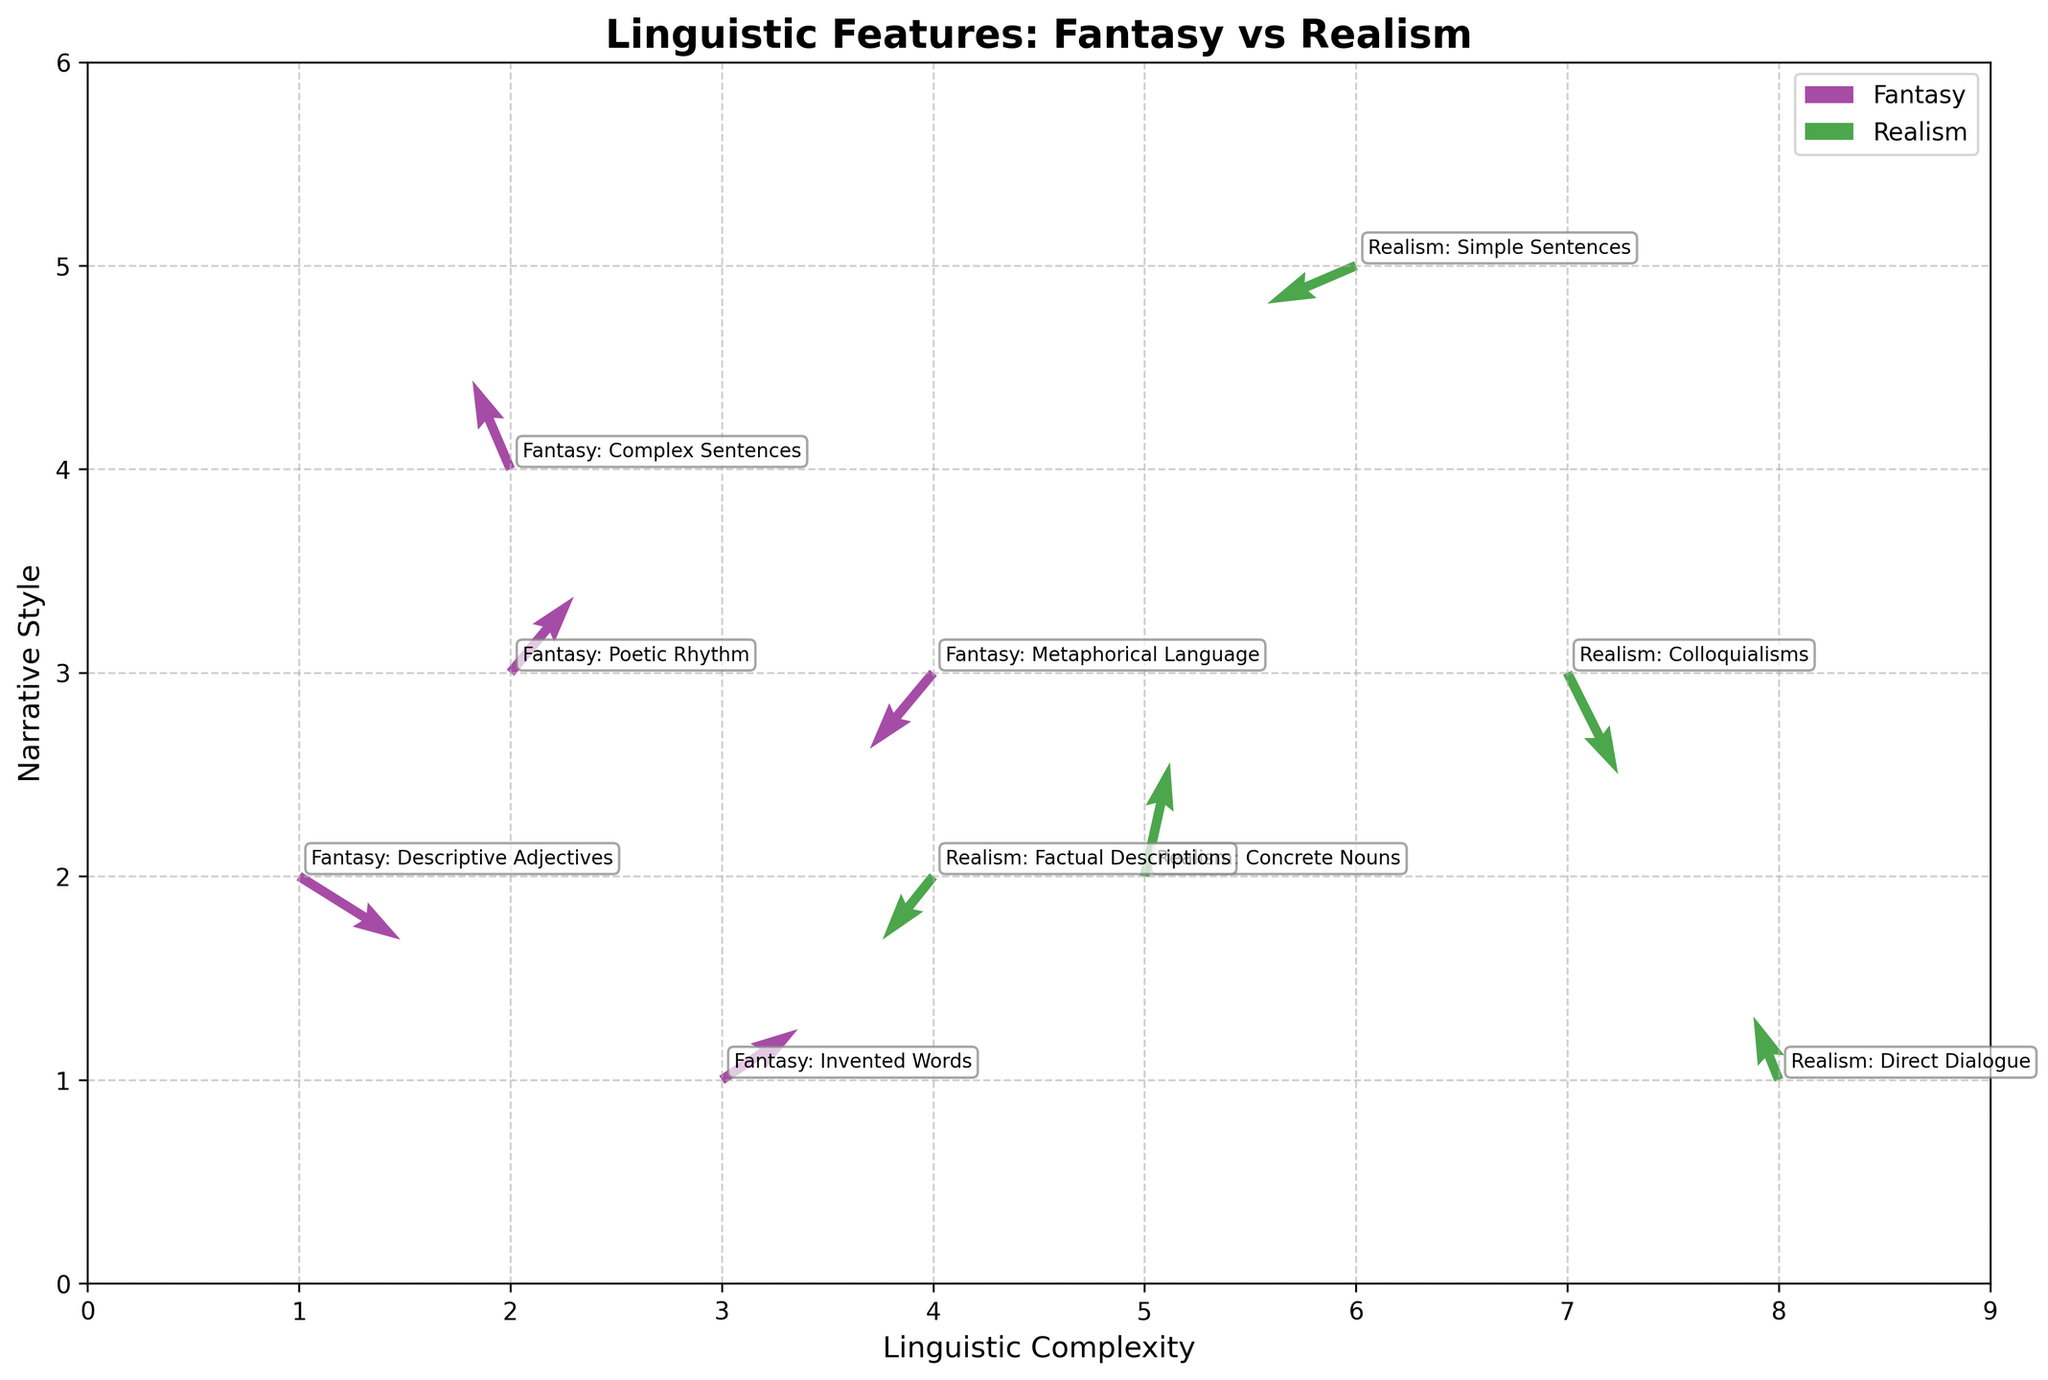What is the title of the plot? The title of the plot is typically found at the top of the figure. It provides a concise summary of what the plot is about.
Answer: Linguistic Features: Fantasy vs Realism How many data points represent fantasy novels? Count the number of data points labeled with "Fantasy" in the plot.
Answer: 5 How many data points represent realism novels? Count the number of data points labeled with "Realism" in the plot.
Answer: 5 What are the axes labeled as? The labels for the axes are provided next to each axis and indicate what each axis represents.
Answer: Linguistic Complexity (x-axis) and Narrative Style (y-axis) What are the colors used to differentiate between fantasy and realism novels? The plot uses different colors to represent different categories, allowing for easy visual differentiation.
Answer: Purple for Fantasy and Green for Realism Which fantasy feature shows the largest positive vertical movement? Look for the largest positive value of 'v' among the fantasy data points.
Answer: Fantasy: Poetic Rhythm (0.6) Which realism feature shows the largest negative horizontal movement? Look for the largest negative value of 'u' among the realism data points.
Answer: Realism: Factual Descriptions (-0.4) Compare the horizontal movement of 'Fantasy: Descriptive Adjectives' and 'Realism: Simple Sentences'. Which one shows greater movement and in which direction? Check the 'u' values for both data points to compare their horizontal movements. 'Fantasy: Descriptive Adjectives': 0.8 and 'Realism: Simple Sentences': -0.7. The greater movement is represented by the magnitude and direction of these values.
Answer: Fantasy: Descriptive Adjectives has greater movement (0.8 to the right) What direction does 'Fantasy: Metaphorical Language' move in both horizontally and vertically? Check the 'u' and 'v' values for this data point. 'Fantasy: Metaphorical Language': -0.5 (horizontal) and -0.6 (vertical).
Answer: Left and downward Do 'Realism: Concrete Nouns' and 'Fantasy: Invented Words' show similar tendencies in narrative style? Compare their 'y' (narrative style) coordinates. 'Realism: Concrete Nouns': 2, 'Fantasy: Invented Words': 1. Since these values are close, they might indicate similar narrative style tendencies.
Answer: No, they are not very similar 